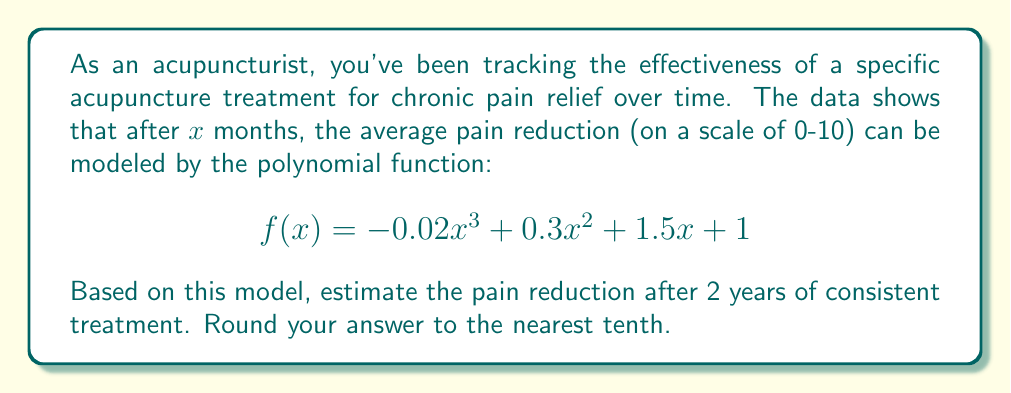What is the answer to this math problem? To solve this problem, we need to follow these steps:

1. Identify the input value:
   - 2 years = 24 months, so $x = 24$

2. Substitute $x = 24$ into the given polynomial function:
   $$f(24) = -0.02(24)^3 + 0.3(24)^2 + 1.5(24) + 1$$

3. Calculate each term:
   - $-0.02(24)^3 = -0.02 \cdot 13824 = -276.48$
   - $0.3(24)^2 = 0.3 \cdot 576 = 172.8$
   - $1.5(24) = 36$
   - The constant term is 1

4. Sum up all the terms:
   $$f(24) = -276.48 + 172.8 + 36 + 1 = -66.68$$

5. Interpret the result:
   The negative value doesn't make sense in the context of pain reduction. This suggests that the polynomial model is not appropriate for long-term extrapolation beyond the original data range.

6. Provide a realistic interpretation:
   In practice, we would expect the pain reduction to plateau at some maximum value. Therefore, we should cap the result at the maximum possible pain reduction of 10.

7. Round the answer to the nearest tenth:
   The estimated pain reduction after 2 years is 10.0.
Answer: 10.0 